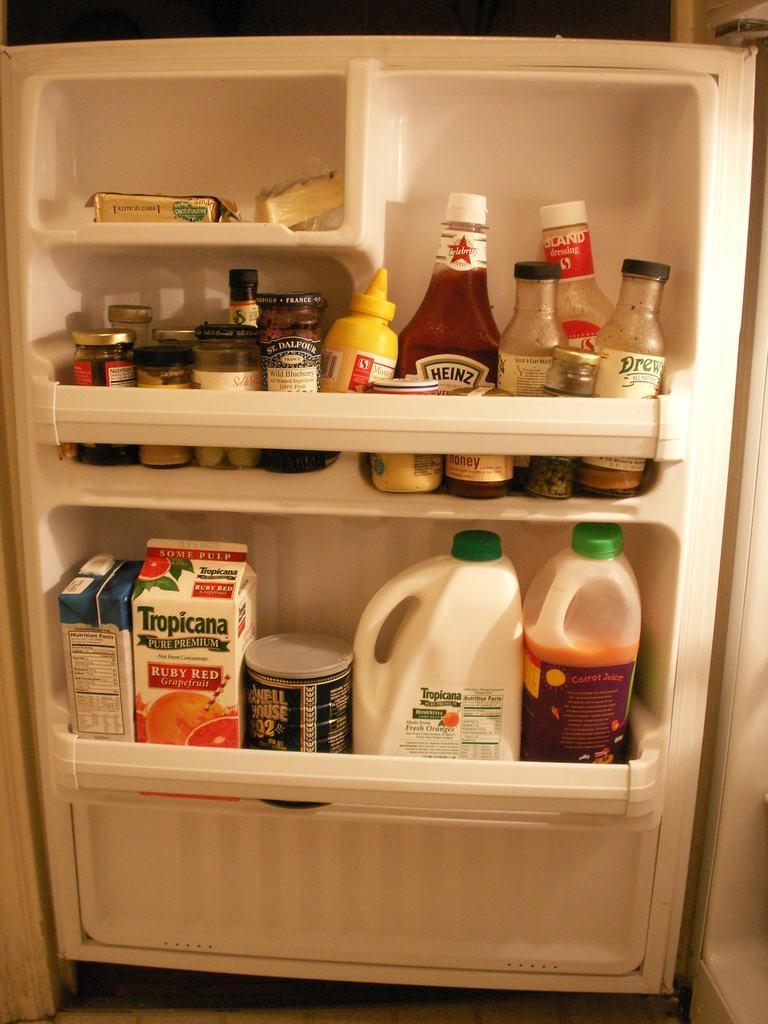What is the main subject of the image? The main subject of the image is a fridge door. What items can be seen on the fridge door? There are bottles, jars, and food packets on the fridge door. What type of clouds can be seen in the image? There are no clouds present in the image, as it is a close-up of a fridge door. 